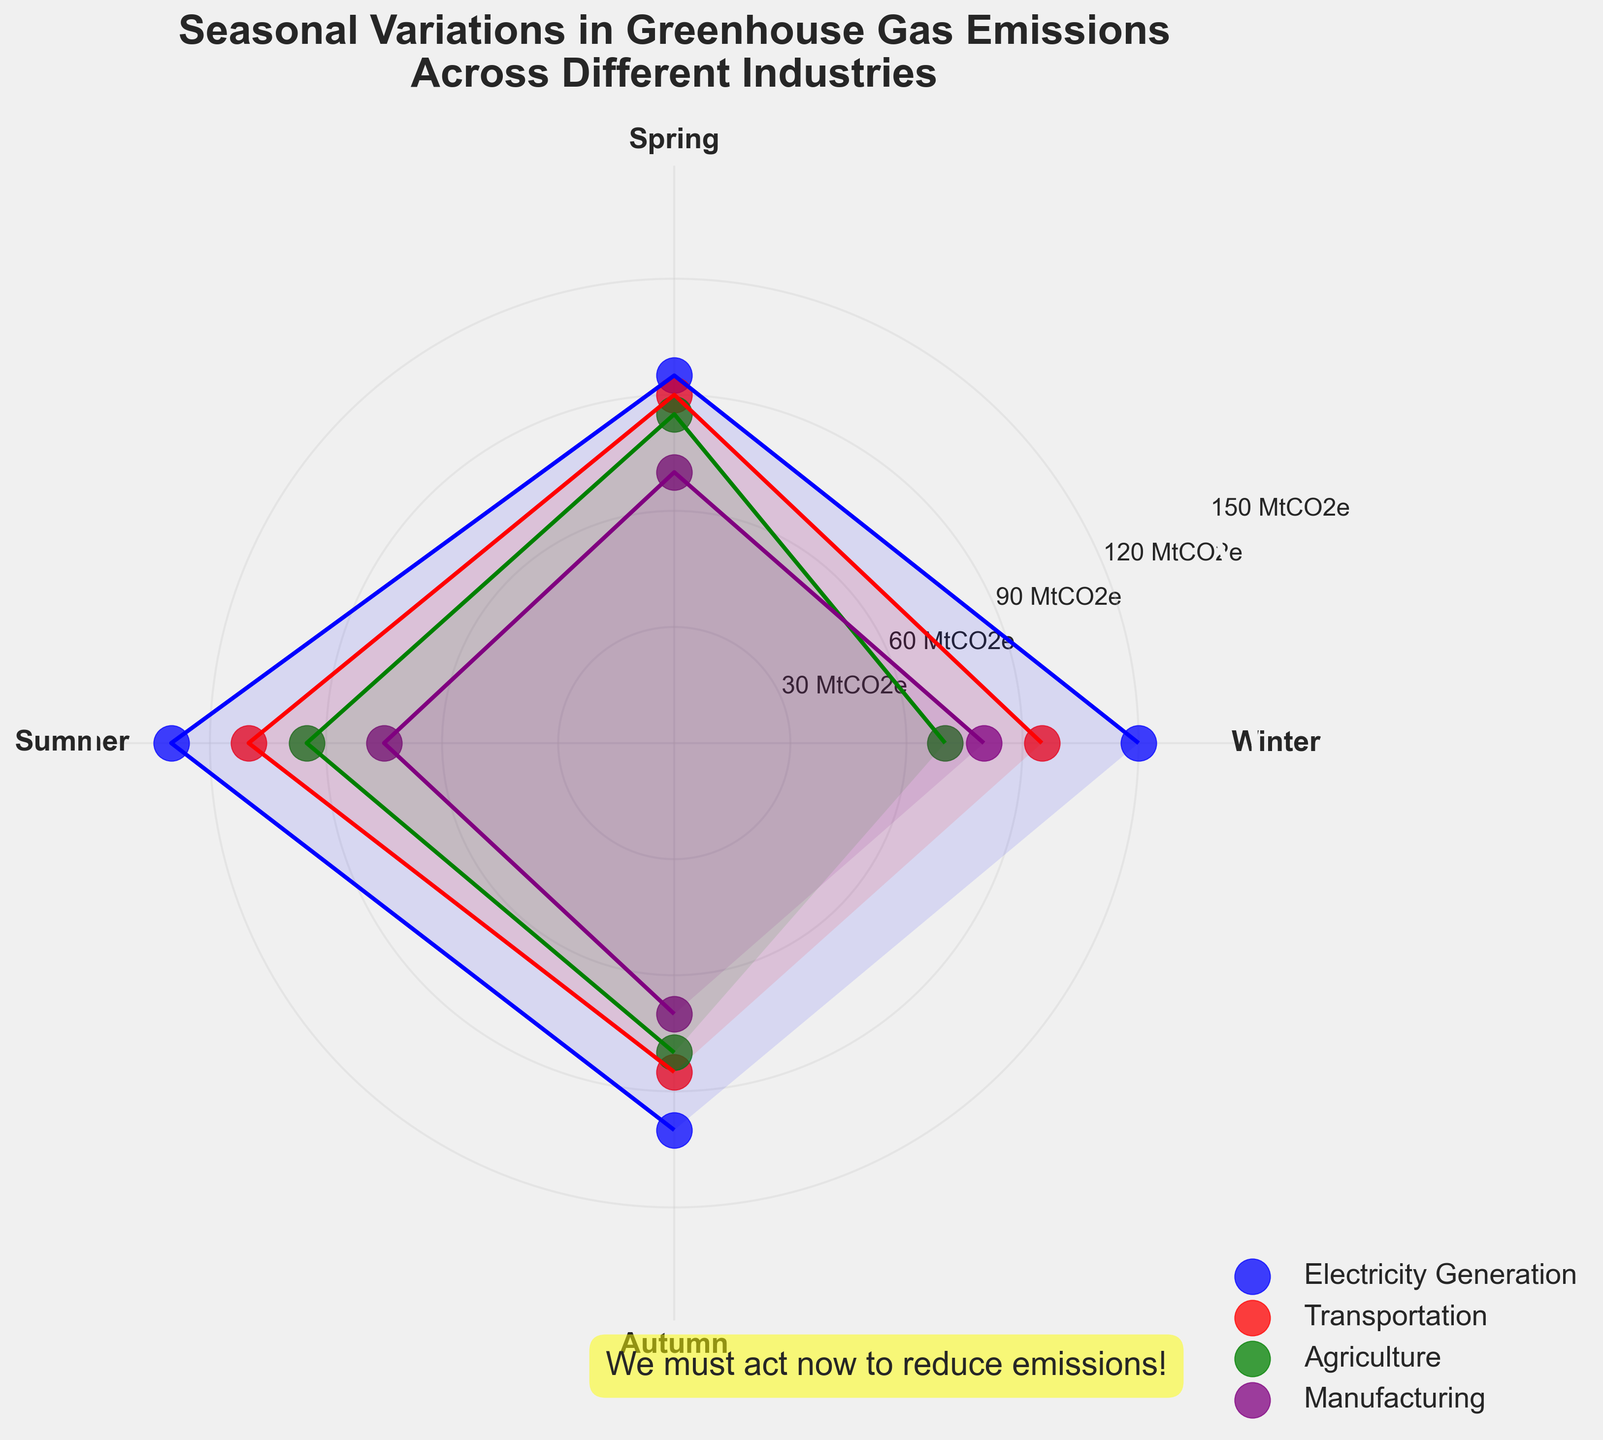How many seasons have data points in the chart? The seasons are displayed as the labels around the polar plot. There are four labels: Winter, Spring, Summer, and Autumn.
Answer: 4 Which industry shows the highest emissions during Summer? By observing the scatter points around the "Summer" label, the highest emissions data point for Summer is at 130 MtCO2e, which is mapped to the Electricity Generation industry, marked in blue.
Answer: Electricity Generation Describe the seasonal trend for the Agriculture industry. The Agriculture industry's emissions for each season are as follows: Winter (70), Spring (85), Summer (95), and Autumn (80). These values show a seasonality where emissions increase from Winter to Summer and slightly decrease in Autumn.
Answer: Increase from Winter to Summer, decrease in Autumn What is the average emissions of the Manufacturing industry across all seasons? The emissions for the Manufacturing industry are the same for Winter (80), Spring (70), Summer (75), and Autumn (70). To find the average: (80 + 70 + 75 + 70) / 4 = 73.75 MtCO2e.
Answer: 73.75 MtCO2e Compare the emissions trends for Electricity Generation and Transportation in Winter. The emissions for Electricity Generation in Winter is 120 MtCO2e, while Transportation in Winter is 95 MtCO2e. Electricity Generation has higher emissions than Transportation during Winter.
Answer: Electricity Generation higher than Transportation Which season has the lowest emissions for Transportation? For Transportation, Winter has 95, Spring has 90, Summer has 110, and Autumn has 85. The lowest emissions occur in Autumn, marked at 85 MtCO2e.
Answer: Autumn Is there any industry where emissions remain relatively constant across seasons? The Manufacturing industry has emissions of 80, 70, 75, and 70 MtCO2e for Winter, Spring, Summer, and Autumn, respectively. The values show small variations and remain relatively constant across the seasons.
Answer: Yes, Manufacturing Identify the industry and season combination that has the highest emissions overall. By looking at all data points, the highest emission value is 130 MtCO2e during Summer for the Electricity Generation industry.
Answer: Electricity Generation in Summer What is the total emissions for the Agriculture industry during the year? The emissions values for Agriculture in each season are Winter (70), Spring (85), Summer (95), and Autumn (80). The total emissions are 70 + 85 + 95 + 80 = 330 MtCO2e.
Answer: 330 MtCO2e 